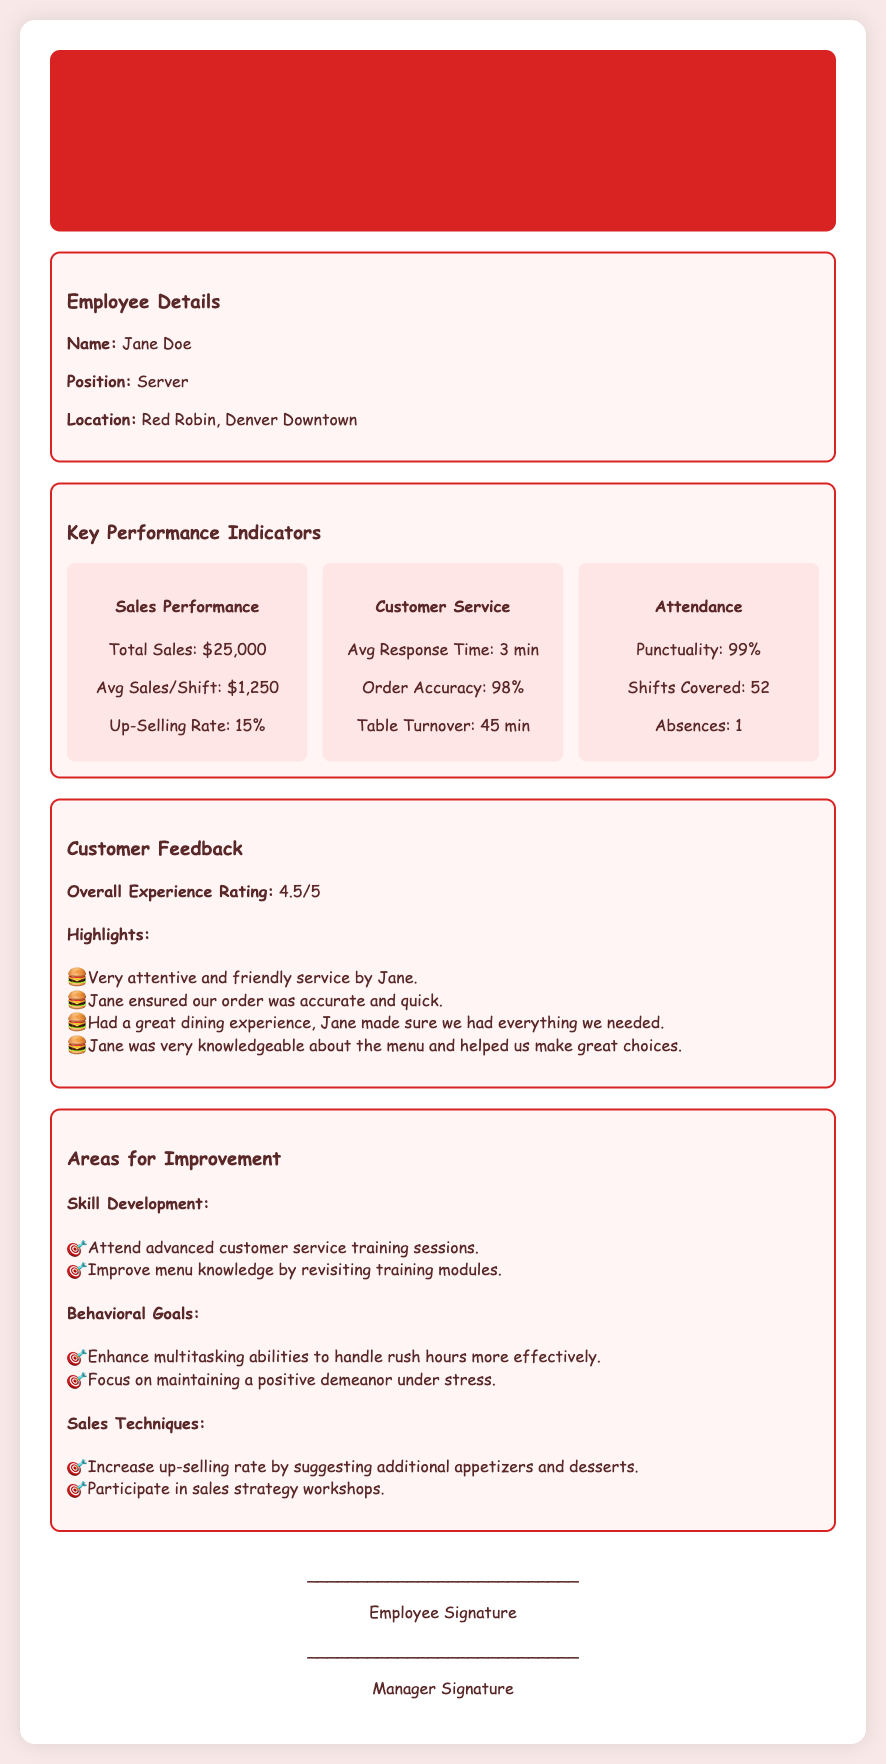What is the name of the employee? The employee's name is mentioned in the Employee Details section of the document.
Answer: Jane Doe What is the total sales figure for Q1 2023? Total Sales is stated in the Key Performance Indicators section, highlighting the overall sales performance.
Answer: $25,000 What is the average response time reported? The average response time is specified under the Customer Service section of the Key Performance Indicators.
Answer: 3 min What is the order accuracy percentage? Order Accuracy is provided in the Customer Service section, indicating the success of orders being correct.
Answer: 98% What training is suggested for skill development? The Areas for Improvement section lists specific training suggestions for employee development.
Answer: Attend advanced customer service training sessions What is the overall experience rating from customers? Customer feedback includes a rating that summarizes overall customer satisfaction.
Answer: 4.5/5 What is the employee's punctuality percentage? Punctuality is indicated as part of the Attendance metrics within the Key Performance Indicators section.
Answer: 99% Which area requires enhancement for better performance during rush hours? The Areas for Improvement mentions specific goals needed to improve in certain situations.
Answer: Multitasking abilities What is the focus of behavioral goals? Behavioral goals set a focus for the employee in terms of personal development within the workplace.
Answer: Maintaining a positive demeanor under stress What is the primary goal for increasing up-selling? The Areas for Improvement includes a section addressing sales techniques focused on improvement.
Answer: Suggesting additional appetizers and desserts 